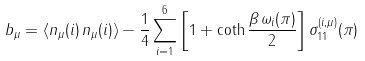<formula> <loc_0><loc_0><loc_500><loc_500>b _ { \mu } = \left \langle n _ { \mu } ( i ) \, n _ { \mu } ( i ) \right \rangle - \frac { 1 } { 4 } \sum _ { i = 1 } ^ { 6 } \left [ 1 + \coth \frac { \beta \, \omega _ { i } ( \pi ) } 2 \right ] \sigma _ { 1 1 } ^ { ( i , \mu ) } ( \pi )</formula> 